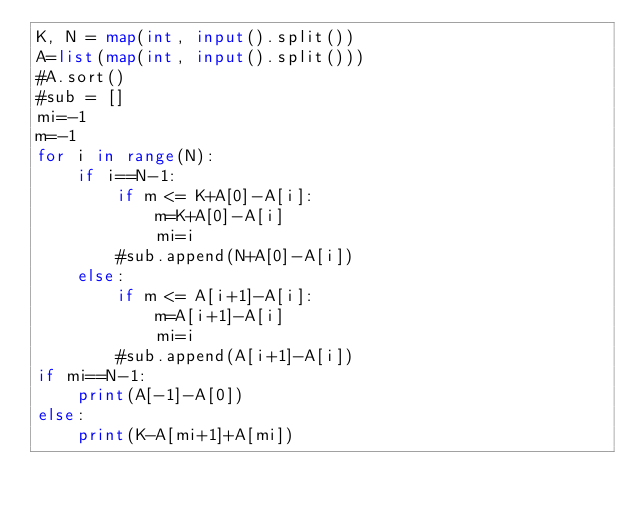<code> <loc_0><loc_0><loc_500><loc_500><_Python_>K, N = map(int, input().split())
A=list(map(int, input().split()))
#A.sort()
#sub = []
mi=-1
m=-1
for i in range(N):
    if i==N-1:
        if m <= K+A[0]-A[i]:
            m=K+A[0]-A[i]
            mi=i
        #sub.append(N+A[0]-A[i])
    else:
        if m <= A[i+1]-A[i]:
            m=A[i+1]-A[i]
            mi=i
        #sub.append(A[i+1]-A[i])
if mi==N-1:
    print(A[-1]-A[0])
else:
    print(K-A[mi+1]+A[mi])</code> 